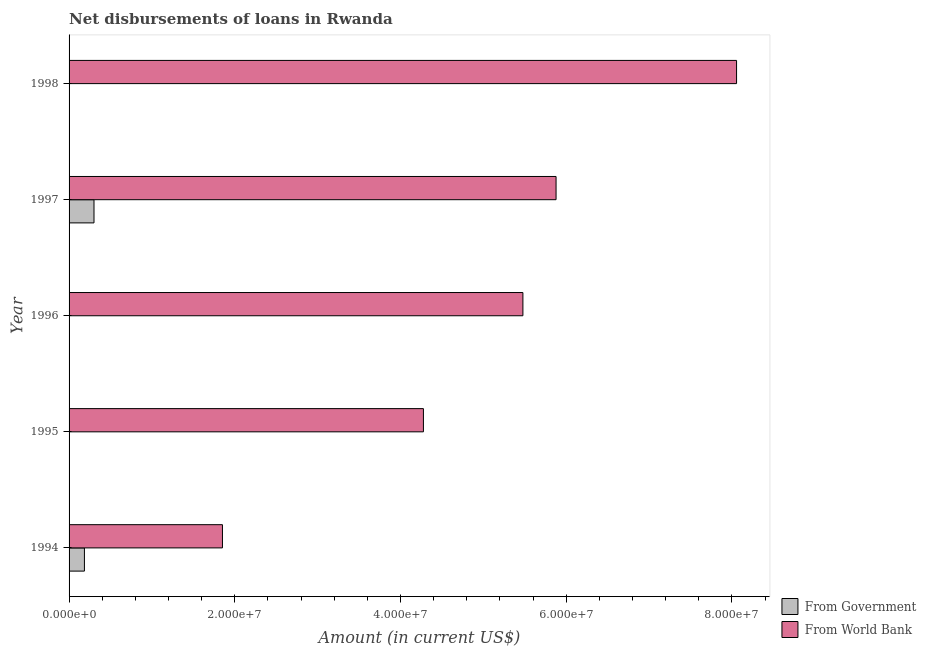Are the number of bars on each tick of the Y-axis equal?
Your answer should be compact. No. How many bars are there on the 1st tick from the top?
Provide a short and direct response. 1. What is the label of the 2nd group of bars from the top?
Ensure brevity in your answer.  1997. What is the net disbursements of loan from world bank in 1994?
Give a very brief answer. 1.85e+07. Across all years, what is the maximum net disbursements of loan from world bank?
Ensure brevity in your answer.  8.06e+07. In which year was the net disbursements of loan from government maximum?
Make the answer very short. 1997. What is the total net disbursements of loan from government in the graph?
Make the answer very short. 4.86e+06. What is the difference between the net disbursements of loan from world bank in 1995 and that in 1996?
Offer a very short reply. -1.20e+07. What is the difference between the net disbursements of loan from world bank in 1994 and the net disbursements of loan from government in 1998?
Give a very brief answer. 1.85e+07. What is the average net disbursements of loan from government per year?
Your response must be concise. 9.72e+05. In the year 1997, what is the difference between the net disbursements of loan from world bank and net disbursements of loan from government?
Your answer should be compact. 5.58e+07. In how many years, is the net disbursements of loan from government greater than 52000000 US$?
Your answer should be very brief. 0. What is the ratio of the net disbursements of loan from world bank in 1995 to that in 1997?
Keep it short and to the point. 0.73. What is the difference between the highest and the second highest net disbursements of loan from world bank?
Make the answer very short. 2.18e+07. What is the difference between the highest and the lowest net disbursements of loan from world bank?
Offer a terse response. 6.21e+07. How many years are there in the graph?
Provide a succinct answer. 5. What is the difference between two consecutive major ticks on the X-axis?
Your answer should be very brief. 2.00e+07. Are the values on the major ticks of X-axis written in scientific E-notation?
Make the answer very short. Yes. Where does the legend appear in the graph?
Ensure brevity in your answer.  Bottom right. How many legend labels are there?
Keep it short and to the point. 2. How are the legend labels stacked?
Provide a succinct answer. Vertical. What is the title of the graph?
Make the answer very short. Net disbursements of loans in Rwanda. What is the label or title of the Y-axis?
Provide a succinct answer. Year. What is the Amount (in current US$) in From Government in 1994?
Offer a terse response. 1.85e+06. What is the Amount (in current US$) of From World Bank in 1994?
Offer a very short reply. 1.85e+07. What is the Amount (in current US$) of From World Bank in 1995?
Your answer should be compact. 4.28e+07. What is the Amount (in current US$) of From Government in 1996?
Your response must be concise. 0. What is the Amount (in current US$) in From World Bank in 1996?
Provide a succinct answer. 5.48e+07. What is the Amount (in current US$) of From Government in 1997?
Provide a succinct answer. 3.01e+06. What is the Amount (in current US$) in From World Bank in 1997?
Your response must be concise. 5.88e+07. What is the Amount (in current US$) of From World Bank in 1998?
Offer a very short reply. 8.06e+07. Across all years, what is the maximum Amount (in current US$) in From Government?
Offer a terse response. 3.01e+06. Across all years, what is the maximum Amount (in current US$) in From World Bank?
Offer a terse response. 8.06e+07. Across all years, what is the minimum Amount (in current US$) in From Government?
Offer a very short reply. 0. Across all years, what is the minimum Amount (in current US$) in From World Bank?
Give a very brief answer. 1.85e+07. What is the total Amount (in current US$) in From Government in the graph?
Keep it short and to the point. 4.86e+06. What is the total Amount (in current US$) of From World Bank in the graph?
Give a very brief answer. 2.55e+08. What is the difference between the Amount (in current US$) in From World Bank in 1994 and that in 1995?
Your answer should be very brief. -2.43e+07. What is the difference between the Amount (in current US$) in From World Bank in 1994 and that in 1996?
Offer a terse response. -3.63e+07. What is the difference between the Amount (in current US$) of From Government in 1994 and that in 1997?
Your answer should be very brief. -1.16e+06. What is the difference between the Amount (in current US$) in From World Bank in 1994 and that in 1997?
Provide a succinct answer. -4.03e+07. What is the difference between the Amount (in current US$) in From World Bank in 1994 and that in 1998?
Your answer should be very brief. -6.21e+07. What is the difference between the Amount (in current US$) of From World Bank in 1995 and that in 1996?
Provide a short and direct response. -1.20e+07. What is the difference between the Amount (in current US$) of From World Bank in 1995 and that in 1997?
Keep it short and to the point. -1.60e+07. What is the difference between the Amount (in current US$) in From World Bank in 1995 and that in 1998?
Your answer should be very brief. -3.78e+07. What is the difference between the Amount (in current US$) in From World Bank in 1996 and that in 1997?
Ensure brevity in your answer.  -4.00e+06. What is the difference between the Amount (in current US$) in From World Bank in 1996 and that in 1998?
Your answer should be very brief. -2.58e+07. What is the difference between the Amount (in current US$) in From World Bank in 1997 and that in 1998?
Your response must be concise. -2.18e+07. What is the difference between the Amount (in current US$) in From Government in 1994 and the Amount (in current US$) in From World Bank in 1995?
Ensure brevity in your answer.  -4.09e+07. What is the difference between the Amount (in current US$) of From Government in 1994 and the Amount (in current US$) of From World Bank in 1996?
Keep it short and to the point. -5.29e+07. What is the difference between the Amount (in current US$) of From Government in 1994 and the Amount (in current US$) of From World Bank in 1997?
Ensure brevity in your answer.  -5.69e+07. What is the difference between the Amount (in current US$) in From Government in 1994 and the Amount (in current US$) in From World Bank in 1998?
Provide a short and direct response. -7.87e+07. What is the difference between the Amount (in current US$) in From Government in 1997 and the Amount (in current US$) in From World Bank in 1998?
Ensure brevity in your answer.  -7.76e+07. What is the average Amount (in current US$) of From Government per year?
Your answer should be compact. 9.72e+05. What is the average Amount (in current US$) of From World Bank per year?
Provide a short and direct response. 5.11e+07. In the year 1994, what is the difference between the Amount (in current US$) of From Government and Amount (in current US$) of From World Bank?
Provide a short and direct response. -1.67e+07. In the year 1997, what is the difference between the Amount (in current US$) of From Government and Amount (in current US$) of From World Bank?
Your response must be concise. -5.58e+07. What is the ratio of the Amount (in current US$) in From World Bank in 1994 to that in 1995?
Your response must be concise. 0.43. What is the ratio of the Amount (in current US$) of From World Bank in 1994 to that in 1996?
Offer a very short reply. 0.34. What is the ratio of the Amount (in current US$) in From Government in 1994 to that in 1997?
Provide a succinct answer. 0.62. What is the ratio of the Amount (in current US$) in From World Bank in 1994 to that in 1997?
Ensure brevity in your answer.  0.32. What is the ratio of the Amount (in current US$) of From World Bank in 1994 to that in 1998?
Provide a short and direct response. 0.23. What is the ratio of the Amount (in current US$) of From World Bank in 1995 to that in 1996?
Offer a very short reply. 0.78. What is the ratio of the Amount (in current US$) of From World Bank in 1995 to that in 1997?
Your answer should be very brief. 0.73. What is the ratio of the Amount (in current US$) of From World Bank in 1995 to that in 1998?
Ensure brevity in your answer.  0.53. What is the ratio of the Amount (in current US$) of From World Bank in 1996 to that in 1997?
Offer a very short reply. 0.93. What is the ratio of the Amount (in current US$) of From World Bank in 1996 to that in 1998?
Offer a terse response. 0.68. What is the ratio of the Amount (in current US$) of From World Bank in 1997 to that in 1998?
Make the answer very short. 0.73. What is the difference between the highest and the second highest Amount (in current US$) in From World Bank?
Offer a very short reply. 2.18e+07. What is the difference between the highest and the lowest Amount (in current US$) in From Government?
Provide a succinct answer. 3.01e+06. What is the difference between the highest and the lowest Amount (in current US$) in From World Bank?
Give a very brief answer. 6.21e+07. 